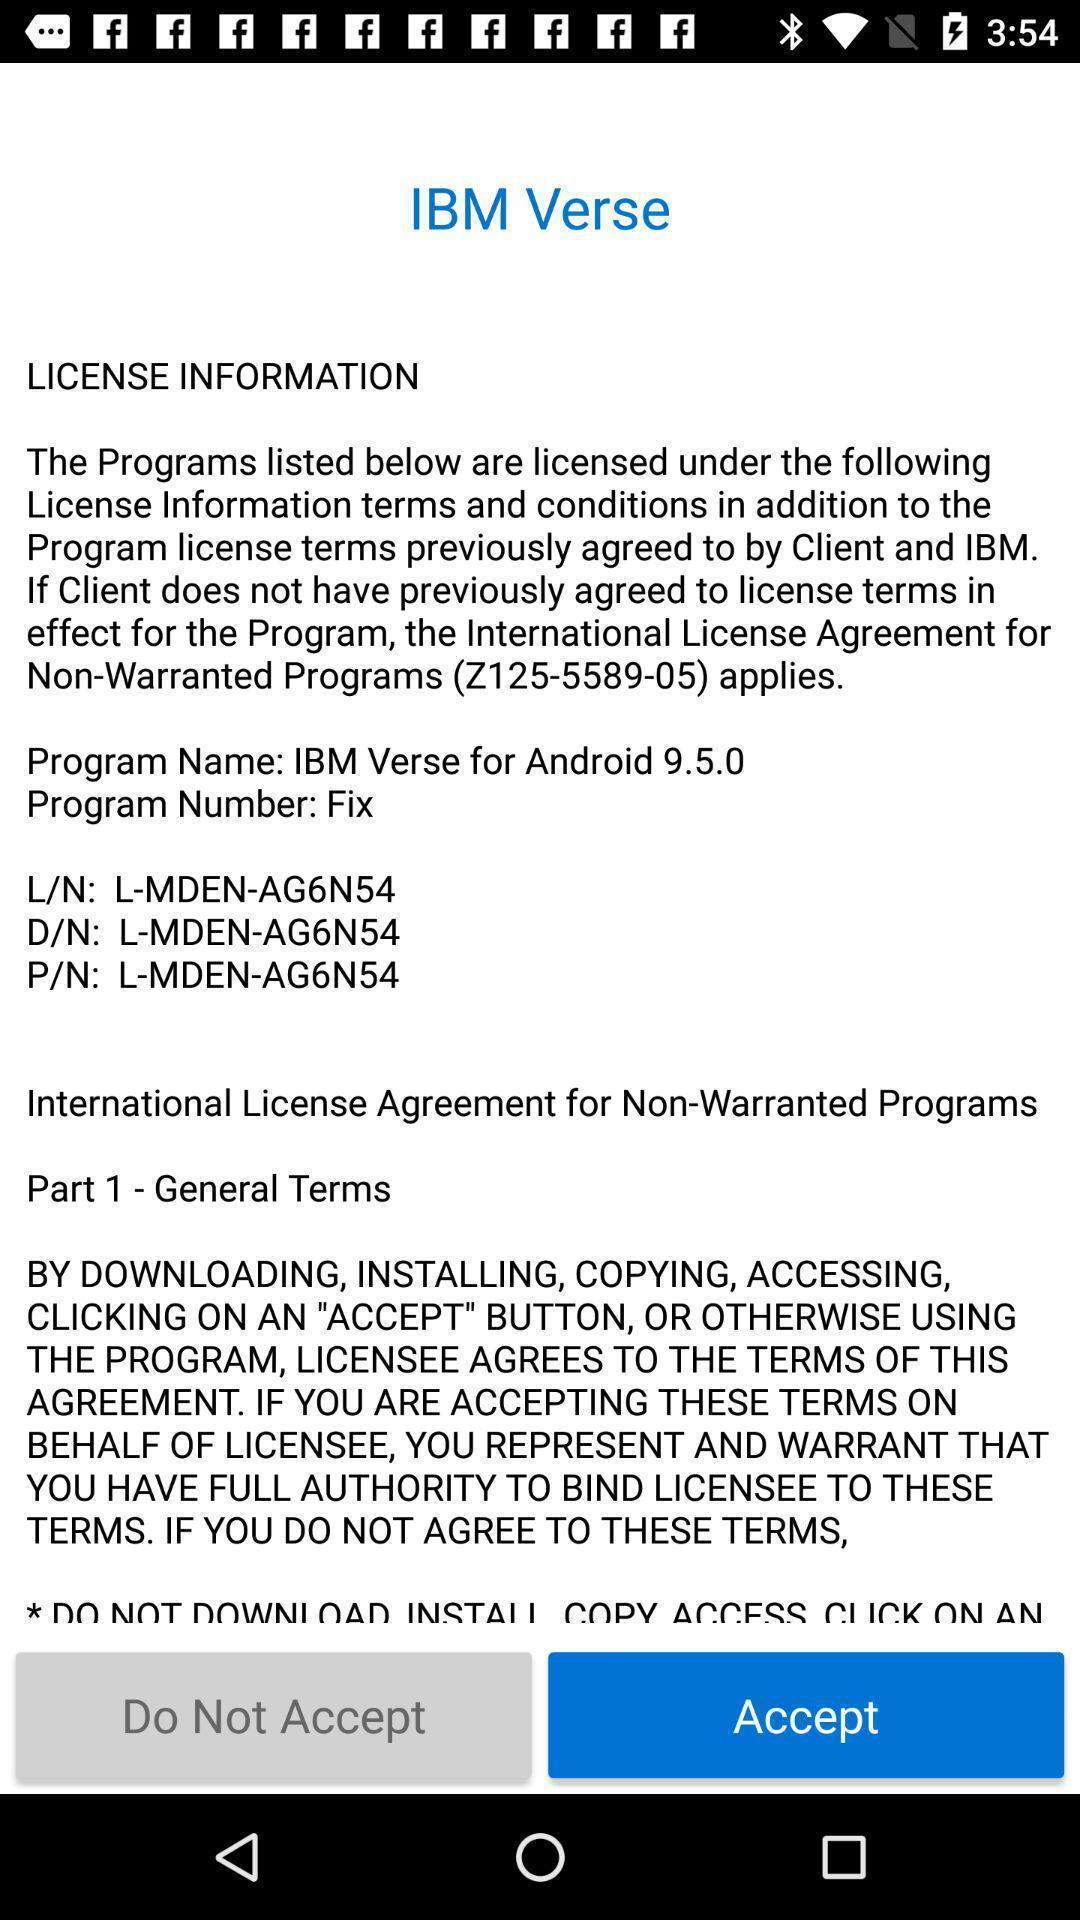Explain the elements present in this screenshot. Page displaying with license information about the application. 